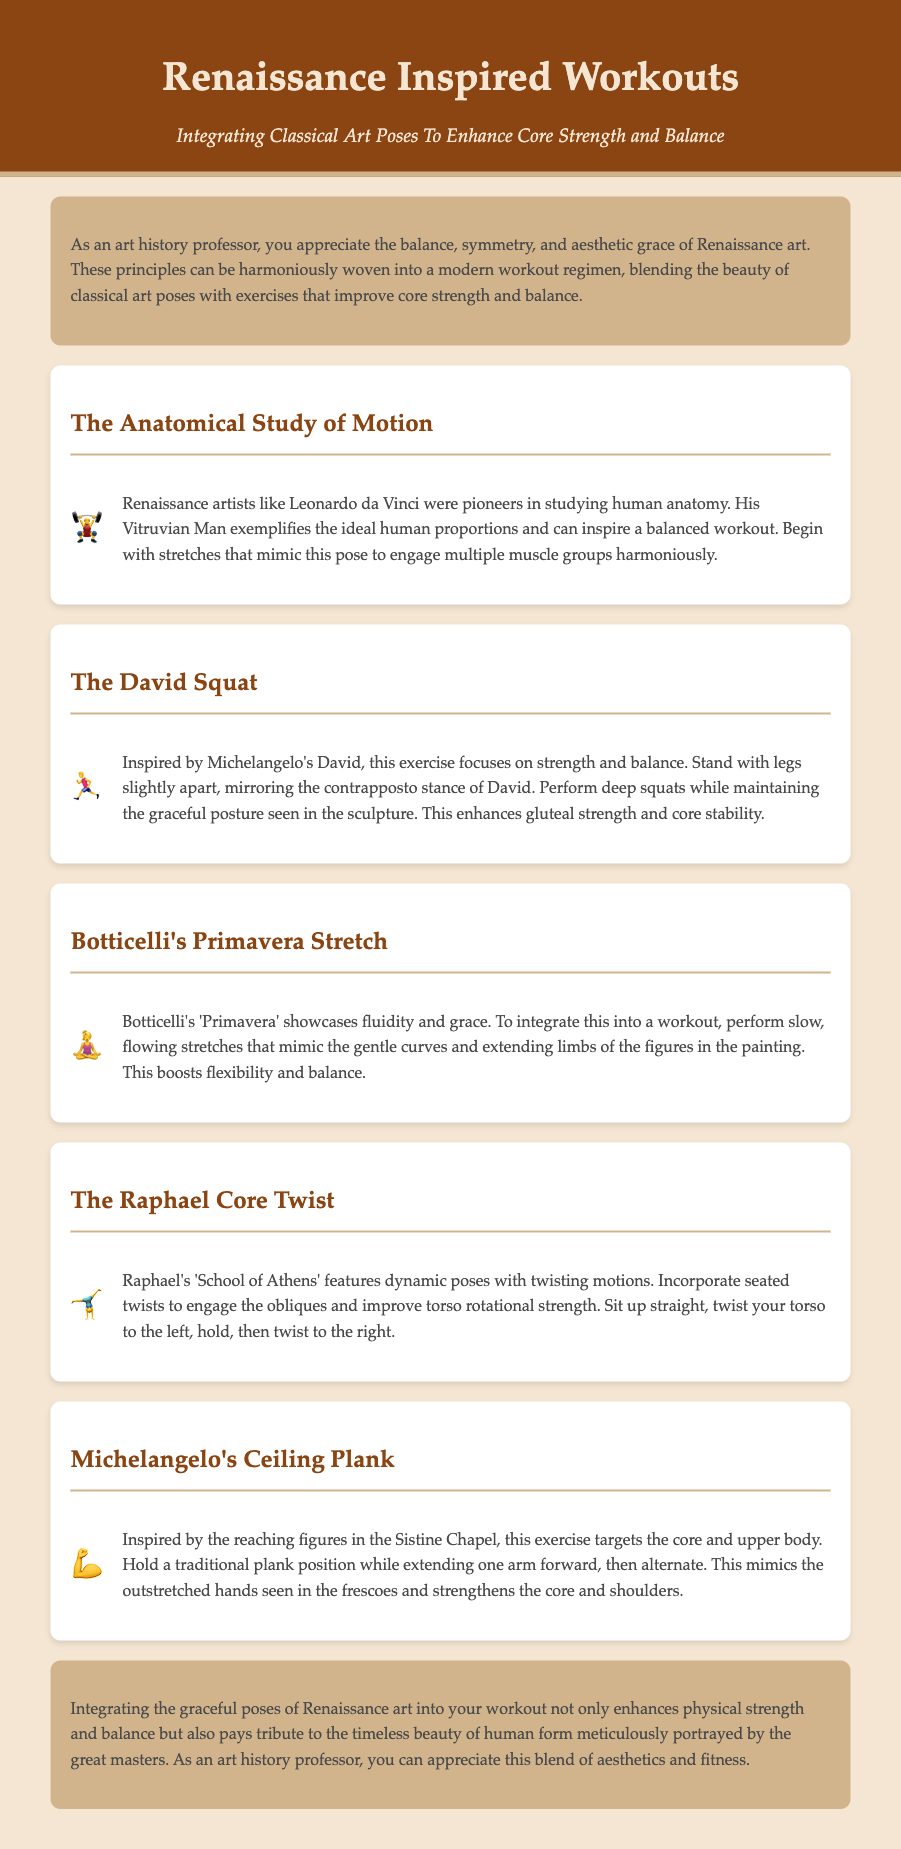what is the title of the document? The title is found in the header section of the document.
Answer: Renaissance Inspired Workouts who is the artist associated with the "David Squat"? The artist is mentioned in the description of the exercise related to the sculpture.
Answer: Michelangelo what exercise is inspired by Botticelli's painting? This relates to the workout section discussing fluidity and grace in the context of a specific piece.
Answer: Primavera Stretch how many specific workouts are listed in the document? The document outlines the number of workout sections detailed within the content.
Answer: Five what is the main benefit of integrating Renaissance poses into workouts? This is discussed in the conclusion, highlighting the blending of aesthetics and fitness.
Answer: Enhances physical strength and balance which Renaissance figure's work is used to inspire the plank exercise? The artist is mentioned in connection to the description of the plank.
Answer: Michelangelo 